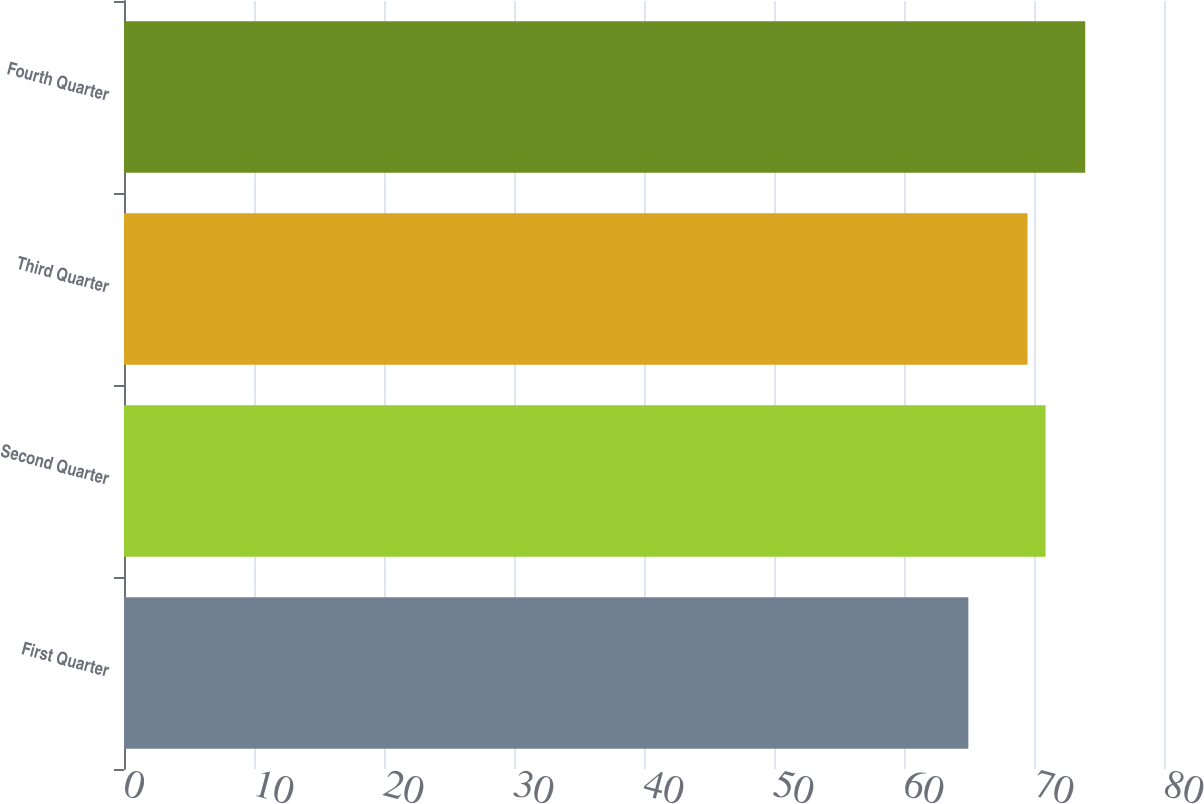Convert chart to OTSL. <chart><loc_0><loc_0><loc_500><loc_500><bar_chart><fcel>First Quarter<fcel>Second Quarter<fcel>Third Quarter<fcel>Fourth Quarter<nl><fcel>64.95<fcel>70.89<fcel>69.5<fcel>73.94<nl></chart> 